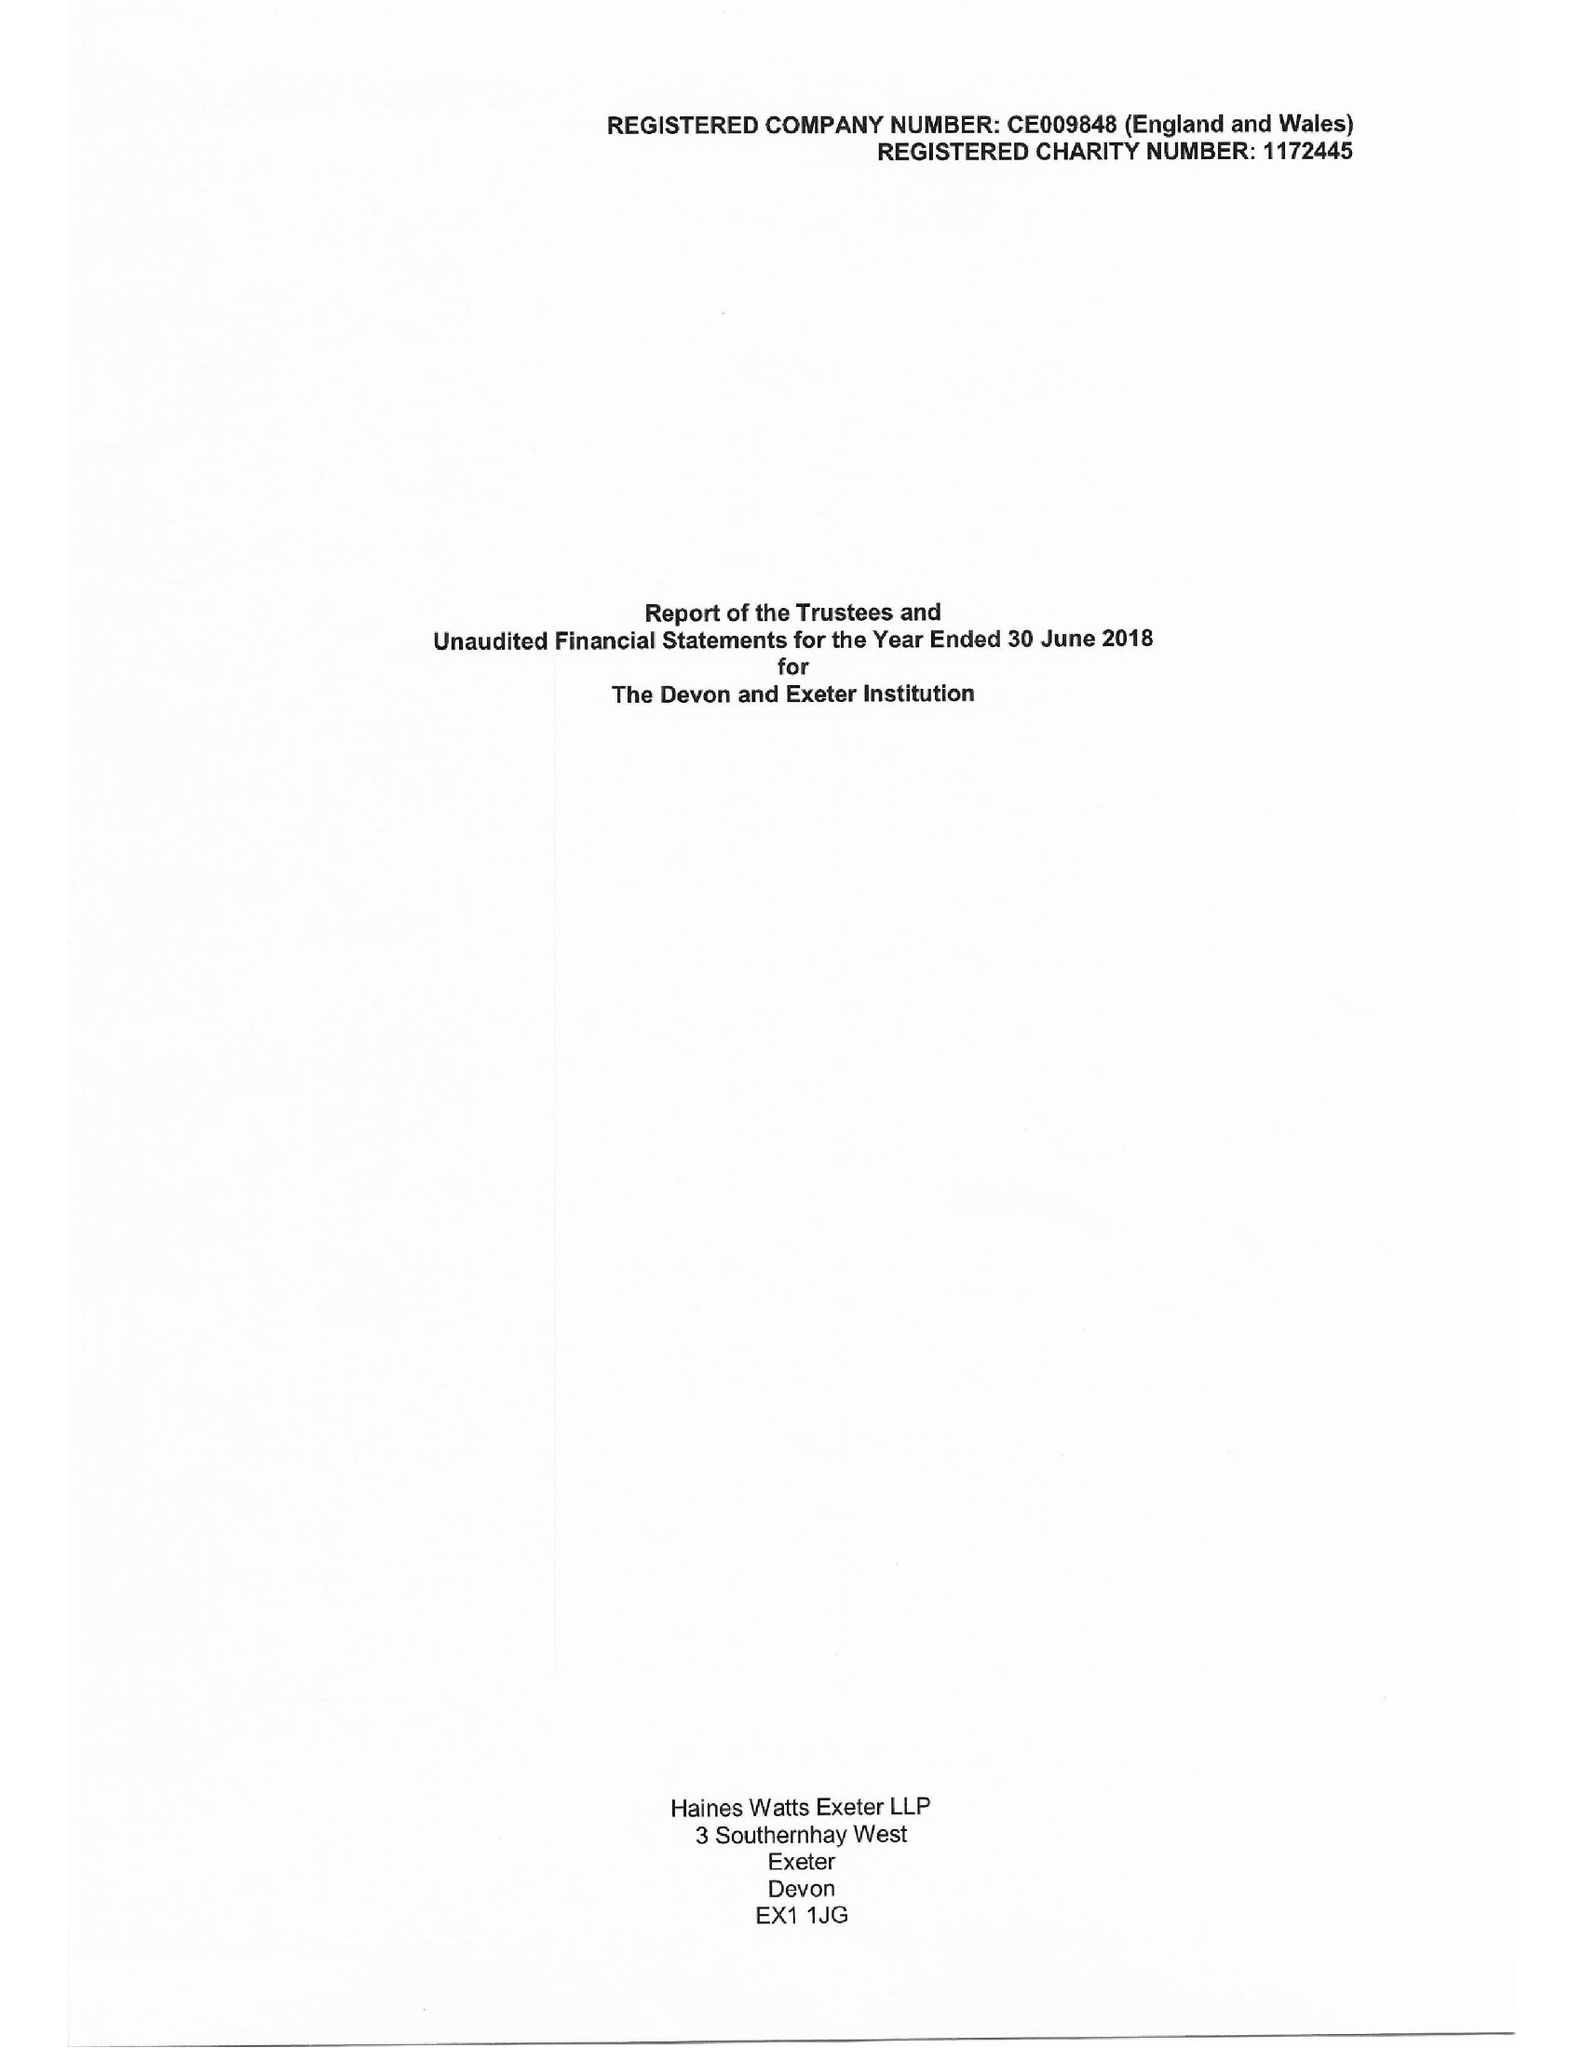What is the value for the address__street_line?
Answer the question using a single word or phrase. 7 CATHEDRAL CLOSE 